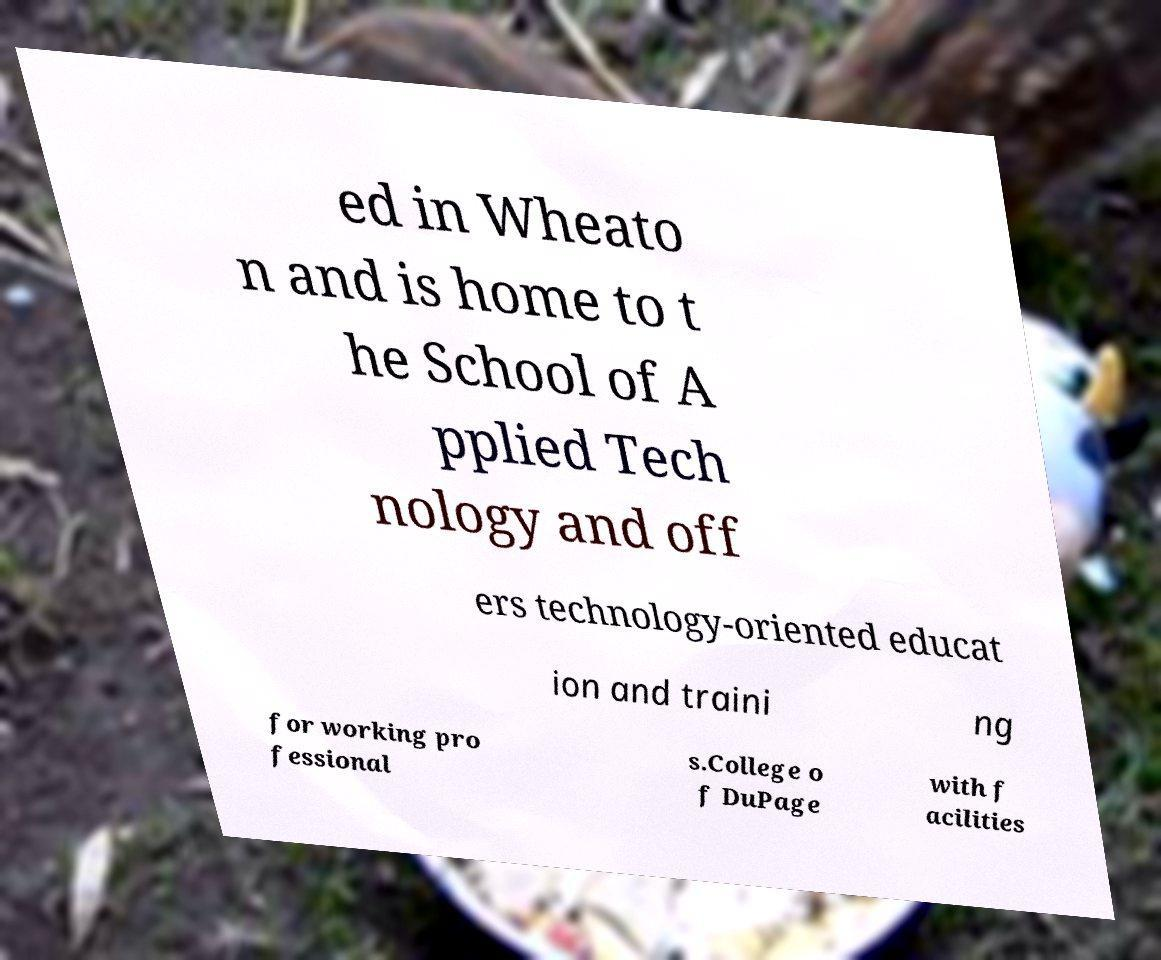I need the written content from this picture converted into text. Can you do that? ed in Wheato n and is home to t he School of A pplied Tech nology and off ers technology-oriented educat ion and traini ng for working pro fessional s.College o f DuPage with f acilities 